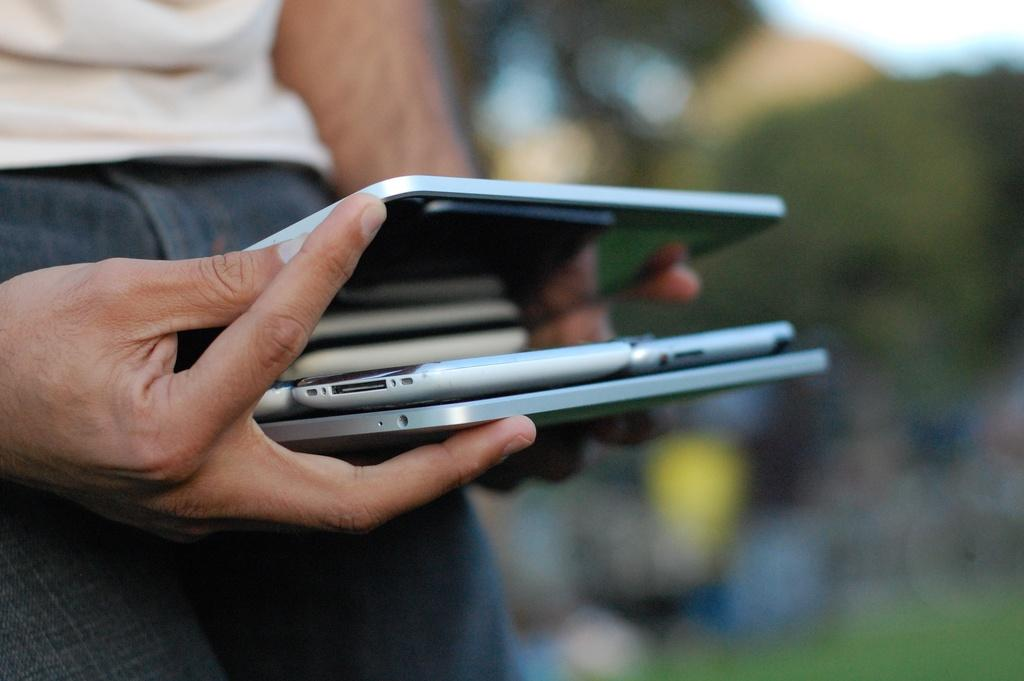What is the main subject of the image? There is a person in the image. What is the person doing in the image? The person is holding devices. Can you describe the background of the image? The background of the image is blurry. How does the stranger in the image turn the crook into a straight line? There is no stranger or crook present in the image; it features a person holding devices. 